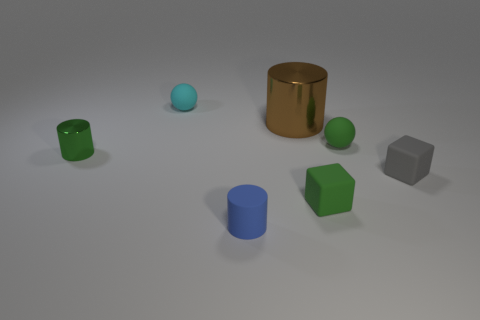There is a green object that is behind the metal thing that is in front of the brown metal cylinder; how big is it?
Ensure brevity in your answer.  Small. What number of cyan things are small matte spheres or small matte blocks?
Your answer should be very brief. 1. Is the number of balls that are to the right of the cyan matte object less than the number of green matte objects that are to the left of the gray matte thing?
Your answer should be compact. Yes. Do the cyan rubber object and the shiny cylinder on the left side of the blue cylinder have the same size?
Your response must be concise. Yes. What number of blue cylinders have the same size as the brown metallic object?
Make the answer very short. 0. How many small things are green metal spheres or spheres?
Provide a short and direct response. 2. Are there any small cyan spheres?
Offer a very short reply. Yes. Is the number of green cylinders to the left of the tiny gray matte object greater than the number of brown shiny cylinders to the left of the large brown cylinder?
Offer a terse response. Yes. What is the color of the matte thing on the right side of the small green matte thing that is behind the small green rubber block?
Your response must be concise. Gray. Are there any rubber spheres of the same color as the tiny metallic cylinder?
Offer a terse response. Yes. 